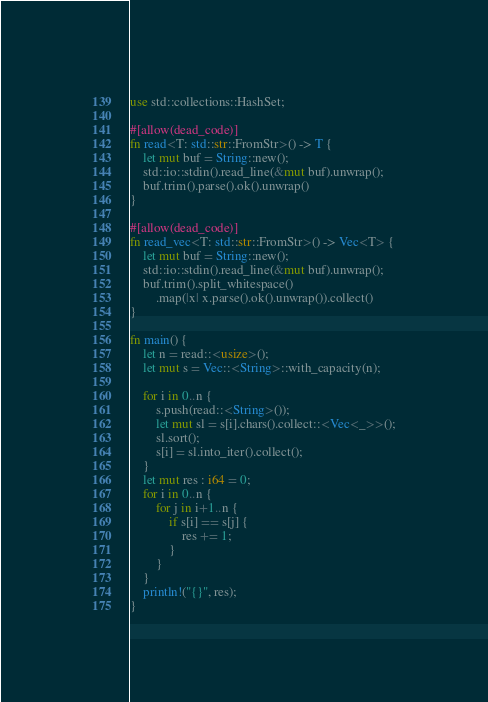Convert code to text. <code><loc_0><loc_0><loc_500><loc_500><_Rust_>use std::collections::HashSet;

#[allow(dead_code)]
fn read<T: std::str::FromStr>() -> T {
    let mut buf = String::new();
    std::io::stdin().read_line(&mut buf).unwrap();
    buf.trim().parse().ok().unwrap()
}

#[allow(dead_code)]
fn read_vec<T: std::str::FromStr>() -> Vec<T> {
    let mut buf = String::new();
    std::io::stdin().read_line(&mut buf).unwrap();
    buf.trim().split_whitespace()
        .map(|x| x.parse().ok().unwrap()).collect()
}

fn main() {
    let n = read::<usize>();
    let mut s = Vec::<String>::with_capacity(n);

    for i in 0..n {
        s.push(read::<String>());
        let mut sl = s[i].chars().collect::<Vec<_>>();
        sl.sort();
        s[i] = sl.into_iter().collect();
    }
    let mut res : i64 = 0;
    for i in 0..n {
        for j in i+1..n {
            if s[i] == s[j] {
                res += 1;
            }
        }
    }
    println!("{}", res);
}
</code> 